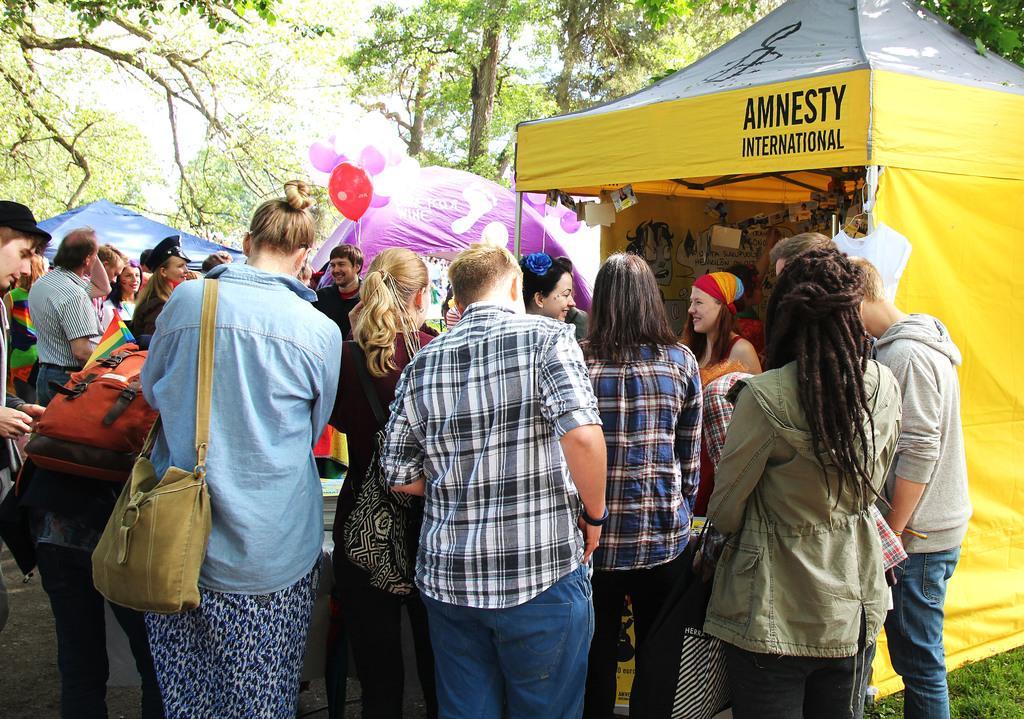Describe this image in one or two sentences. In the mage it looks like a Expo there is a lot of crowd outside the stalls, in the image there are total three stalls, in the background there are some trees and sky. 